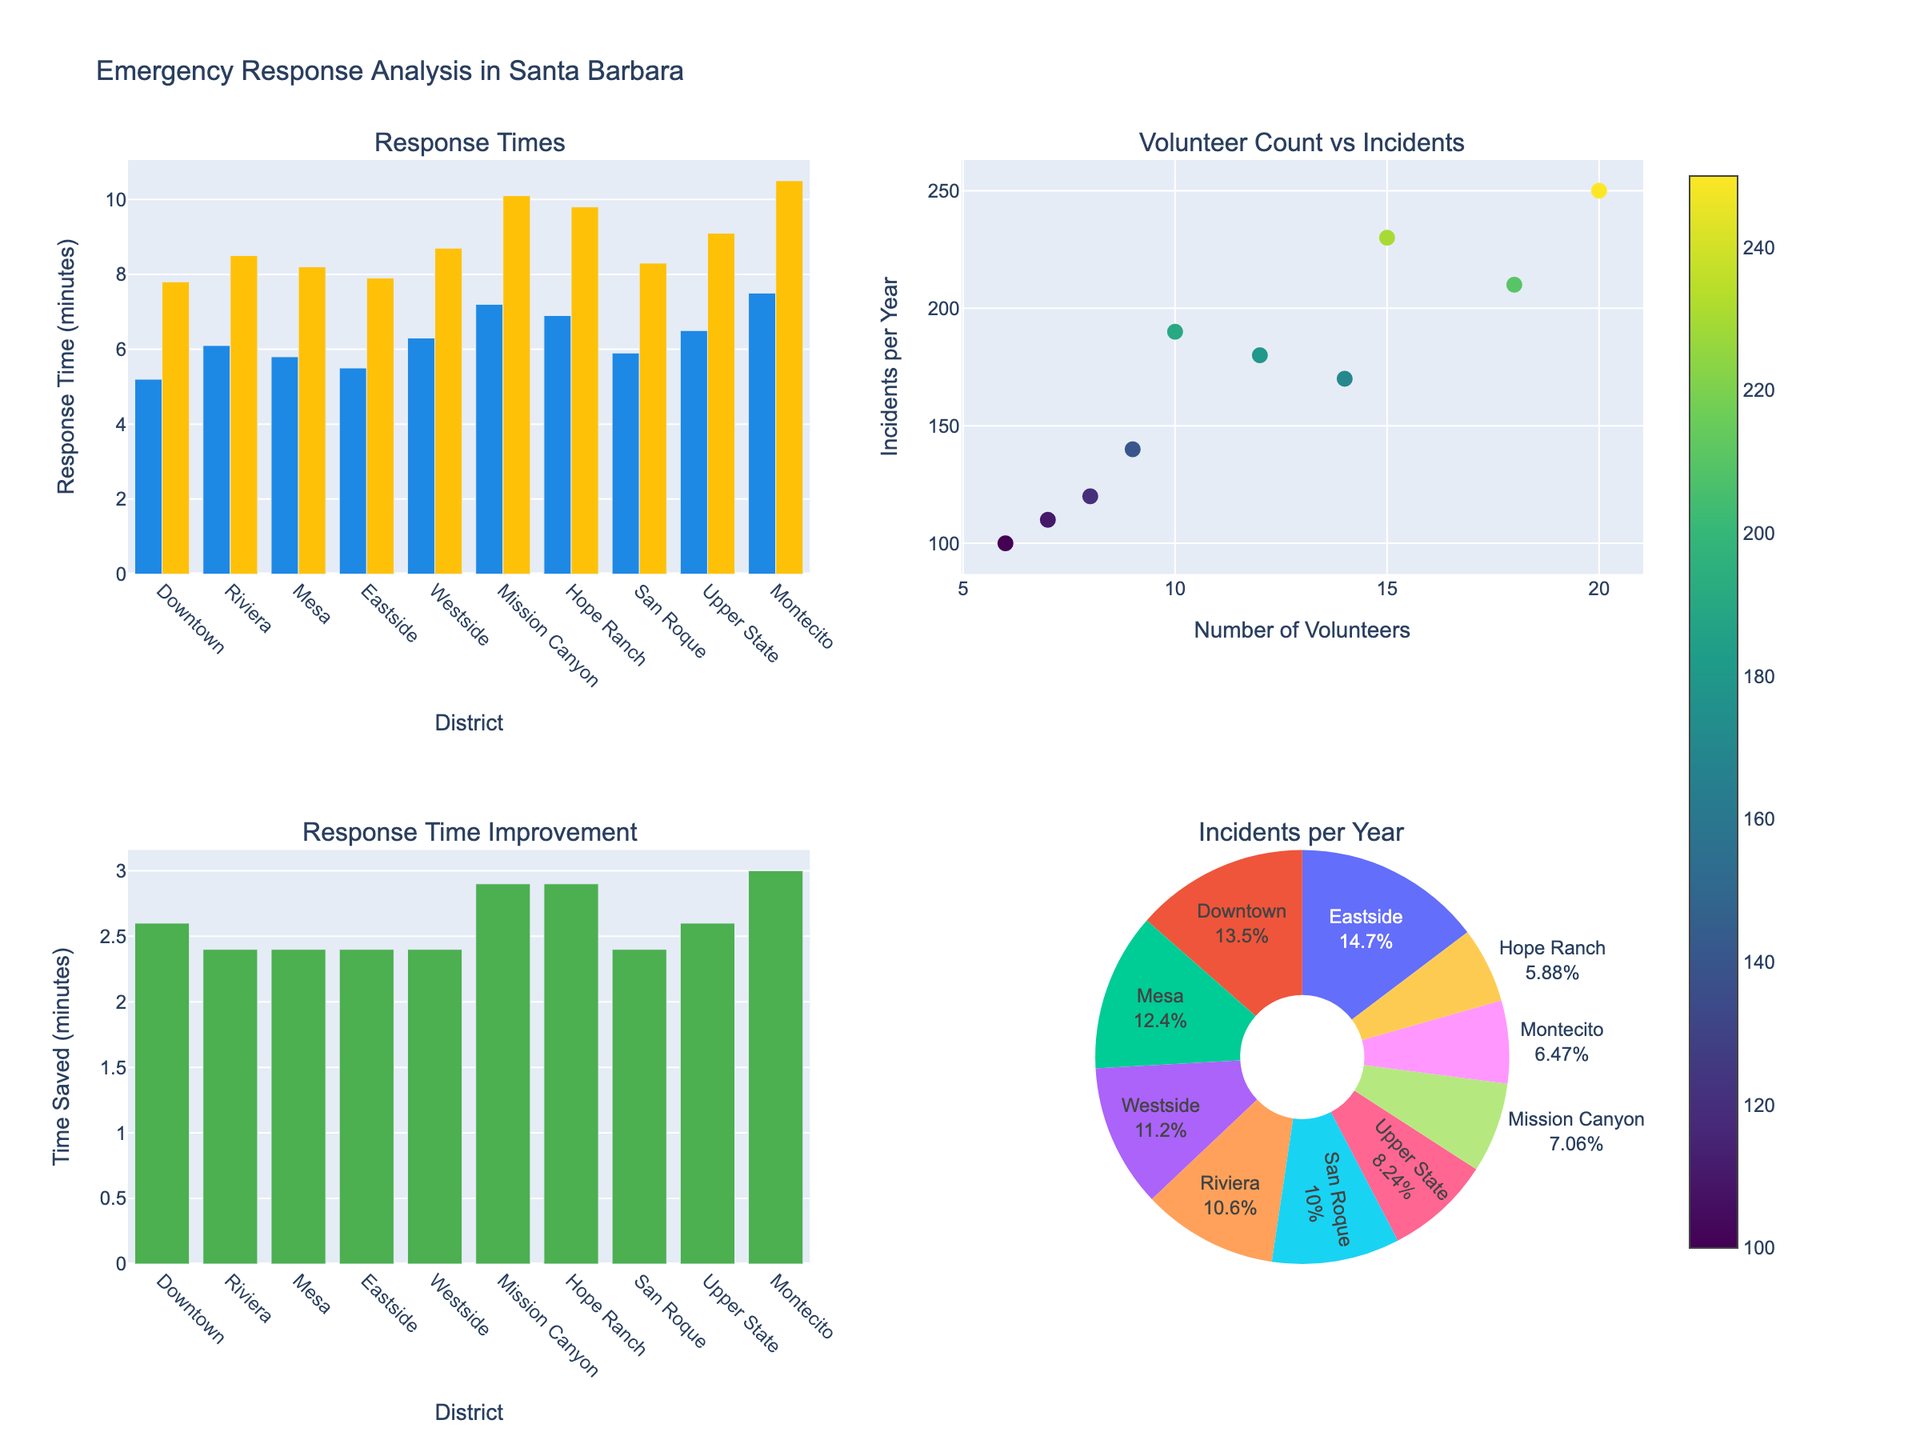Which district has the lowest response time with volunteer firefighters? To find the district with the lowest response time when volunteer firefighters are present, check the bar heights in the "Response Times" subplot under "With Volunteers". Downtown has the lowest response time of 5.2 minutes.
Answer: Downtown How many districts have a response time improvement of more than 3 minutes when volunteer firefighters are present? Response time improvement is calculated by subtracting the "With Volunteers" bar heights from the "Without Volunteers" bar heights in the "Response Time Improvement" subplot. Mission Canyon (2.9), Hope Ranch (2.9), Montecito (3.0), and Upper State (2.6) have improvements of more than 3 minutes. This includes Montecito.
Answer: 1 What is the average response time improvement across all districts? The response time improvement for each district is calculated by subtracting the "With Volunteers" response times from the "Without Volunteers" response times. Sum these improvements and then divide by the number of districts: (2.6 + 2.4 + 2.4 + 2.4 + 2.4 + 2.9 + 2.9 + 2.4 + 2.6 + 3.0)/10 = 2.6 minutes.
Answer: 2.6 minutes Which district has the highest number of incidents per year? Check the "Incidents per Year" axis in the pie chart or the scatter plot for the marker with the highest y-axis value. Eastside, with 250 incidents per year, has the highest number.
Answer: Eastside Is there a correlation between the number of volunteers and the number of incidents per year? In the "Volunteer Count vs Incidents" scatter plot, look for a pattern or trend in the dots. The data points are scattered without a clear upward or downward trend, indicating there is no strong correlation.
Answer: No strong correlation Which district benefits the most from having volunteer firefighters in terms of time saved? Check the bars' heights tallied in the "Response Time Improvement" subplot. Montecito has the highest improvement of 3.0 minutes saved.
Answer: Montecito How many total incidents per year are recorded in all districts combined? Sum the "Incidents per Year" values from the pie chart or scatter plot. Total=230+180+210+250+190+120+100+170+140+110=1700 incidents per year.
Answer: 1700 Which district has the highest response time without volunteer firefighters? In the "Without Volunteers" bar chart of the "Response Times" subplot, the highest bar corresponds to Montecito, with a response time of 10.5 minutes.
Answer: Montecito 